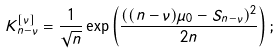<formula> <loc_0><loc_0><loc_500><loc_500>K ^ { [ \nu ] } _ { n - \nu } = \frac { 1 } { \sqrt { n } } \exp \left ( \frac { ( ( n - \nu ) \mu _ { 0 } - S _ { n - \nu } ) ^ { 2 } } { 2 n } \right ) ;</formula> 